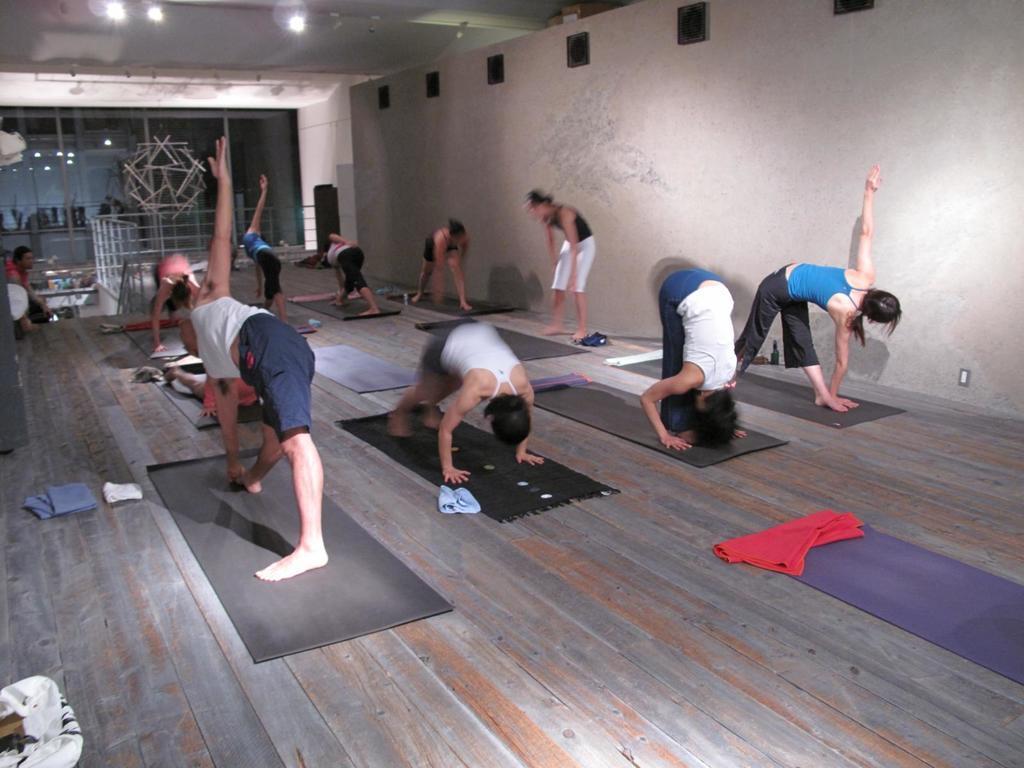Could you give a brief overview of what you see in this image? This image consists of many people doing exercise. At the bottom, there are mats on the floor. The floor is made up of wood. In the background, we can see a railing along with stairs. At the top, there is a roof. 